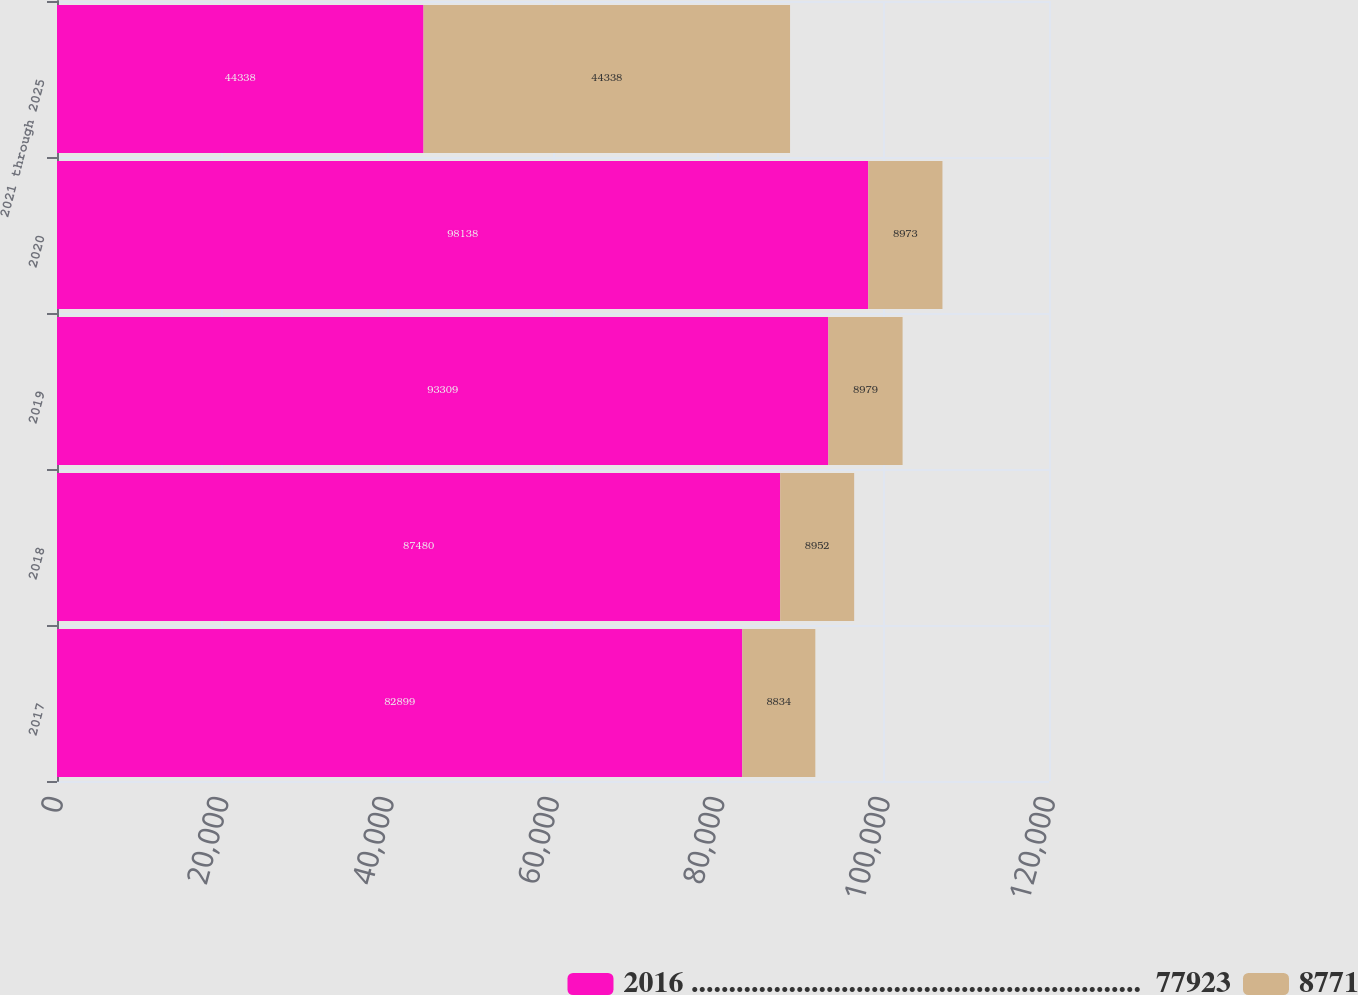Convert chart to OTSL. <chart><loc_0><loc_0><loc_500><loc_500><stacked_bar_chart><ecel><fcel>2017<fcel>2018<fcel>2019<fcel>2020<fcel>2021 through 2025<nl><fcel>2016 ............................................................  77923<fcel>82899<fcel>87480<fcel>93309<fcel>98138<fcel>44338<nl><fcel>8771<fcel>8834<fcel>8952<fcel>8979<fcel>8973<fcel>44338<nl></chart> 